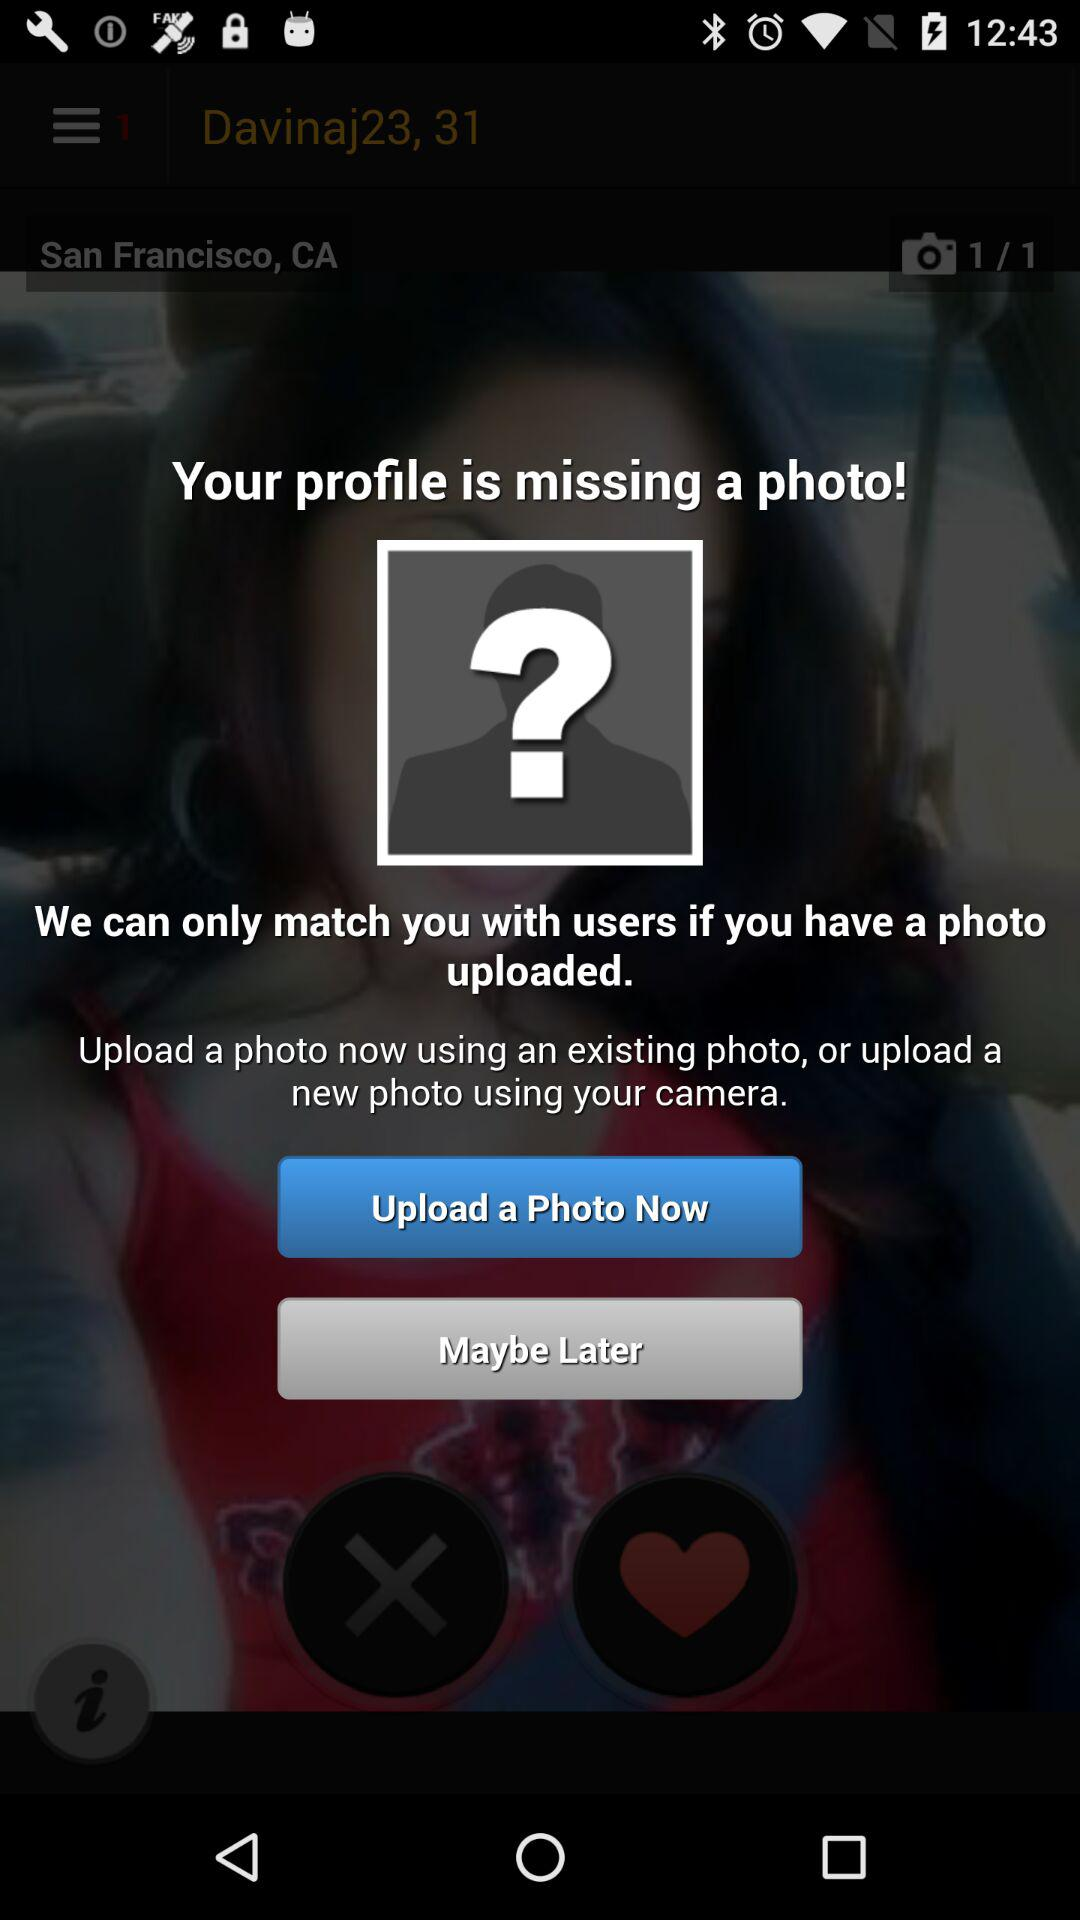How many photos are available to upload?
Answer the question using a single word or phrase. 1 